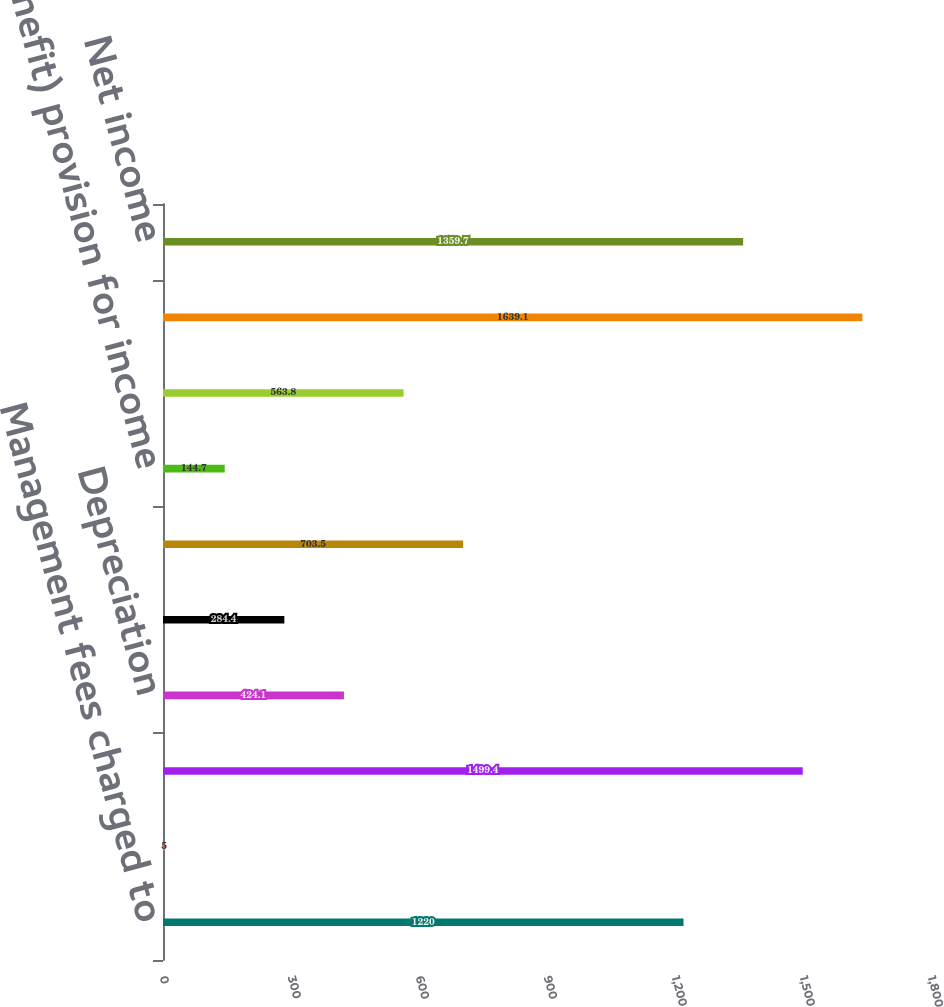Convert chart. <chart><loc_0><loc_0><loc_500><loc_500><bar_chart><fcel>Management fees charged to<fcel>Investment and other income<fcel>Operating costs<fcel>Depreciation<fcel>Interest<fcel>Loss before income taxes and<fcel>(Benefit) provision for income<fcel>Loss before equity in net<fcel>Equity in net earnings of<fcel>Net income<nl><fcel>1220<fcel>5<fcel>1499.4<fcel>424.1<fcel>284.4<fcel>703.5<fcel>144.7<fcel>563.8<fcel>1639.1<fcel>1359.7<nl></chart> 